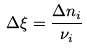Convert formula to latex. <formula><loc_0><loc_0><loc_500><loc_500>\Delta \xi = \frac { \Delta n _ { i } } { \nu _ { i } }</formula> 